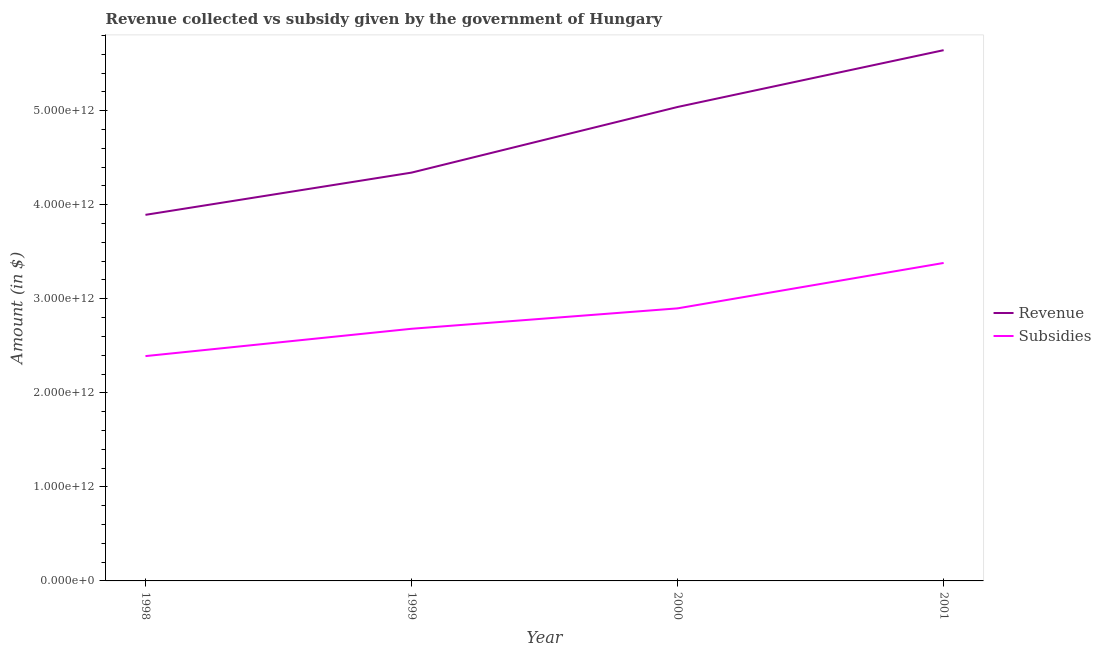How many different coloured lines are there?
Offer a very short reply. 2. Does the line corresponding to amount of revenue collected intersect with the line corresponding to amount of subsidies given?
Offer a terse response. No. What is the amount of revenue collected in 1998?
Your answer should be very brief. 3.89e+12. Across all years, what is the maximum amount of subsidies given?
Provide a succinct answer. 3.38e+12. Across all years, what is the minimum amount of subsidies given?
Give a very brief answer. 2.39e+12. In which year was the amount of subsidies given minimum?
Make the answer very short. 1998. What is the total amount of revenue collected in the graph?
Your response must be concise. 1.89e+13. What is the difference between the amount of revenue collected in 1999 and that in 2000?
Your answer should be very brief. -6.98e+11. What is the difference between the amount of revenue collected in 1998 and the amount of subsidies given in 1999?
Make the answer very short. 1.21e+12. What is the average amount of revenue collected per year?
Offer a terse response. 4.73e+12. In the year 1999, what is the difference between the amount of revenue collected and amount of subsidies given?
Offer a very short reply. 1.66e+12. What is the ratio of the amount of subsidies given in 1998 to that in 1999?
Keep it short and to the point. 0.89. Is the amount of subsidies given in 1998 less than that in 1999?
Your answer should be very brief. Yes. Is the difference between the amount of subsidies given in 1999 and 2001 greater than the difference between the amount of revenue collected in 1999 and 2001?
Provide a short and direct response. Yes. What is the difference between the highest and the second highest amount of subsidies given?
Give a very brief answer. 4.83e+11. What is the difference between the highest and the lowest amount of subsidies given?
Your answer should be very brief. 9.90e+11. In how many years, is the amount of revenue collected greater than the average amount of revenue collected taken over all years?
Keep it short and to the point. 2. Is the sum of the amount of revenue collected in 1998 and 2001 greater than the maximum amount of subsidies given across all years?
Give a very brief answer. Yes. Does the amount of revenue collected monotonically increase over the years?
Provide a succinct answer. Yes. Is the amount of subsidies given strictly greater than the amount of revenue collected over the years?
Provide a short and direct response. No. Is the amount of revenue collected strictly less than the amount of subsidies given over the years?
Keep it short and to the point. No. What is the difference between two consecutive major ticks on the Y-axis?
Ensure brevity in your answer.  1.00e+12. Does the graph contain any zero values?
Your answer should be very brief. No. Does the graph contain grids?
Your response must be concise. No. Where does the legend appear in the graph?
Your answer should be very brief. Center right. What is the title of the graph?
Your answer should be compact. Revenue collected vs subsidy given by the government of Hungary. Does "Primary income" appear as one of the legend labels in the graph?
Your answer should be compact. No. What is the label or title of the Y-axis?
Your answer should be very brief. Amount (in $). What is the Amount (in $) of Revenue in 1998?
Keep it short and to the point. 3.89e+12. What is the Amount (in $) in Subsidies in 1998?
Keep it short and to the point. 2.39e+12. What is the Amount (in $) of Revenue in 1999?
Provide a succinct answer. 4.34e+12. What is the Amount (in $) of Subsidies in 1999?
Your response must be concise. 2.68e+12. What is the Amount (in $) in Revenue in 2000?
Ensure brevity in your answer.  5.04e+12. What is the Amount (in $) of Subsidies in 2000?
Your answer should be very brief. 2.90e+12. What is the Amount (in $) of Revenue in 2001?
Give a very brief answer. 5.64e+12. What is the Amount (in $) of Subsidies in 2001?
Make the answer very short. 3.38e+12. Across all years, what is the maximum Amount (in $) of Revenue?
Offer a very short reply. 5.64e+12. Across all years, what is the maximum Amount (in $) in Subsidies?
Make the answer very short. 3.38e+12. Across all years, what is the minimum Amount (in $) in Revenue?
Offer a terse response. 3.89e+12. Across all years, what is the minimum Amount (in $) in Subsidies?
Your response must be concise. 2.39e+12. What is the total Amount (in $) in Revenue in the graph?
Offer a very short reply. 1.89e+13. What is the total Amount (in $) of Subsidies in the graph?
Offer a very short reply. 1.14e+13. What is the difference between the Amount (in $) in Revenue in 1998 and that in 1999?
Your response must be concise. -4.49e+11. What is the difference between the Amount (in $) of Subsidies in 1998 and that in 1999?
Give a very brief answer. -2.91e+11. What is the difference between the Amount (in $) in Revenue in 1998 and that in 2000?
Your answer should be very brief. -1.15e+12. What is the difference between the Amount (in $) of Subsidies in 1998 and that in 2000?
Ensure brevity in your answer.  -5.08e+11. What is the difference between the Amount (in $) in Revenue in 1998 and that in 2001?
Provide a short and direct response. -1.75e+12. What is the difference between the Amount (in $) of Subsidies in 1998 and that in 2001?
Your answer should be very brief. -9.90e+11. What is the difference between the Amount (in $) in Revenue in 1999 and that in 2000?
Offer a terse response. -6.98e+11. What is the difference between the Amount (in $) of Subsidies in 1999 and that in 2000?
Offer a very short reply. -2.17e+11. What is the difference between the Amount (in $) of Revenue in 1999 and that in 2001?
Provide a short and direct response. -1.30e+12. What is the difference between the Amount (in $) of Subsidies in 1999 and that in 2001?
Make the answer very short. -7.00e+11. What is the difference between the Amount (in $) of Revenue in 2000 and that in 2001?
Make the answer very short. -6.04e+11. What is the difference between the Amount (in $) in Subsidies in 2000 and that in 2001?
Provide a short and direct response. -4.83e+11. What is the difference between the Amount (in $) in Revenue in 1998 and the Amount (in $) in Subsidies in 1999?
Make the answer very short. 1.21e+12. What is the difference between the Amount (in $) in Revenue in 1998 and the Amount (in $) in Subsidies in 2000?
Keep it short and to the point. 9.94e+11. What is the difference between the Amount (in $) of Revenue in 1998 and the Amount (in $) of Subsidies in 2001?
Offer a terse response. 5.12e+11. What is the difference between the Amount (in $) in Revenue in 1999 and the Amount (in $) in Subsidies in 2000?
Your answer should be very brief. 1.44e+12. What is the difference between the Amount (in $) of Revenue in 1999 and the Amount (in $) of Subsidies in 2001?
Offer a terse response. 9.61e+11. What is the difference between the Amount (in $) in Revenue in 2000 and the Amount (in $) in Subsidies in 2001?
Your answer should be very brief. 1.66e+12. What is the average Amount (in $) in Revenue per year?
Offer a very short reply. 4.73e+12. What is the average Amount (in $) in Subsidies per year?
Provide a succinct answer. 2.84e+12. In the year 1998, what is the difference between the Amount (in $) of Revenue and Amount (in $) of Subsidies?
Your answer should be compact. 1.50e+12. In the year 1999, what is the difference between the Amount (in $) of Revenue and Amount (in $) of Subsidies?
Offer a terse response. 1.66e+12. In the year 2000, what is the difference between the Amount (in $) of Revenue and Amount (in $) of Subsidies?
Offer a terse response. 2.14e+12. In the year 2001, what is the difference between the Amount (in $) in Revenue and Amount (in $) in Subsidies?
Your answer should be compact. 2.26e+12. What is the ratio of the Amount (in $) of Revenue in 1998 to that in 1999?
Ensure brevity in your answer.  0.9. What is the ratio of the Amount (in $) in Subsidies in 1998 to that in 1999?
Offer a very short reply. 0.89. What is the ratio of the Amount (in $) of Revenue in 1998 to that in 2000?
Provide a short and direct response. 0.77. What is the ratio of the Amount (in $) of Subsidies in 1998 to that in 2000?
Give a very brief answer. 0.82. What is the ratio of the Amount (in $) of Revenue in 1998 to that in 2001?
Your response must be concise. 0.69. What is the ratio of the Amount (in $) in Subsidies in 1998 to that in 2001?
Provide a short and direct response. 0.71. What is the ratio of the Amount (in $) in Revenue in 1999 to that in 2000?
Offer a terse response. 0.86. What is the ratio of the Amount (in $) in Subsidies in 1999 to that in 2000?
Your answer should be compact. 0.93. What is the ratio of the Amount (in $) in Revenue in 1999 to that in 2001?
Offer a terse response. 0.77. What is the ratio of the Amount (in $) in Subsidies in 1999 to that in 2001?
Your answer should be very brief. 0.79. What is the ratio of the Amount (in $) of Revenue in 2000 to that in 2001?
Your answer should be very brief. 0.89. What is the ratio of the Amount (in $) in Subsidies in 2000 to that in 2001?
Offer a terse response. 0.86. What is the difference between the highest and the second highest Amount (in $) of Revenue?
Your answer should be compact. 6.04e+11. What is the difference between the highest and the second highest Amount (in $) of Subsidies?
Your answer should be compact. 4.83e+11. What is the difference between the highest and the lowest Amount (in $) of Revenue?
Give a very brief answer. 1.75e+12. What is the difference between the highest and the lowest Amount (in $) of Subsidies?
Give a very brief answer. 9.90e+11. 